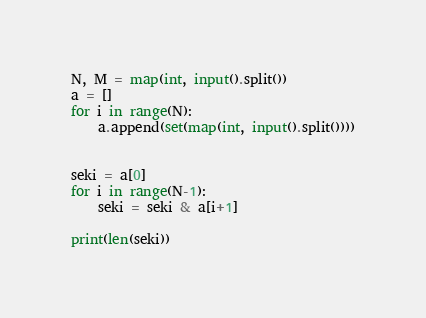Convert code to text. <code><loc_0><loc_0><loc_500><loc_500><_Python_>N, M = map(int, input().split())
a = []
for i in range(N):
    a.append(set(map(int, input().split())))


seki = a[0]
for i in range(N-1):
    seki = seki & a[i+1]
    
print(len(seki))
</code> 